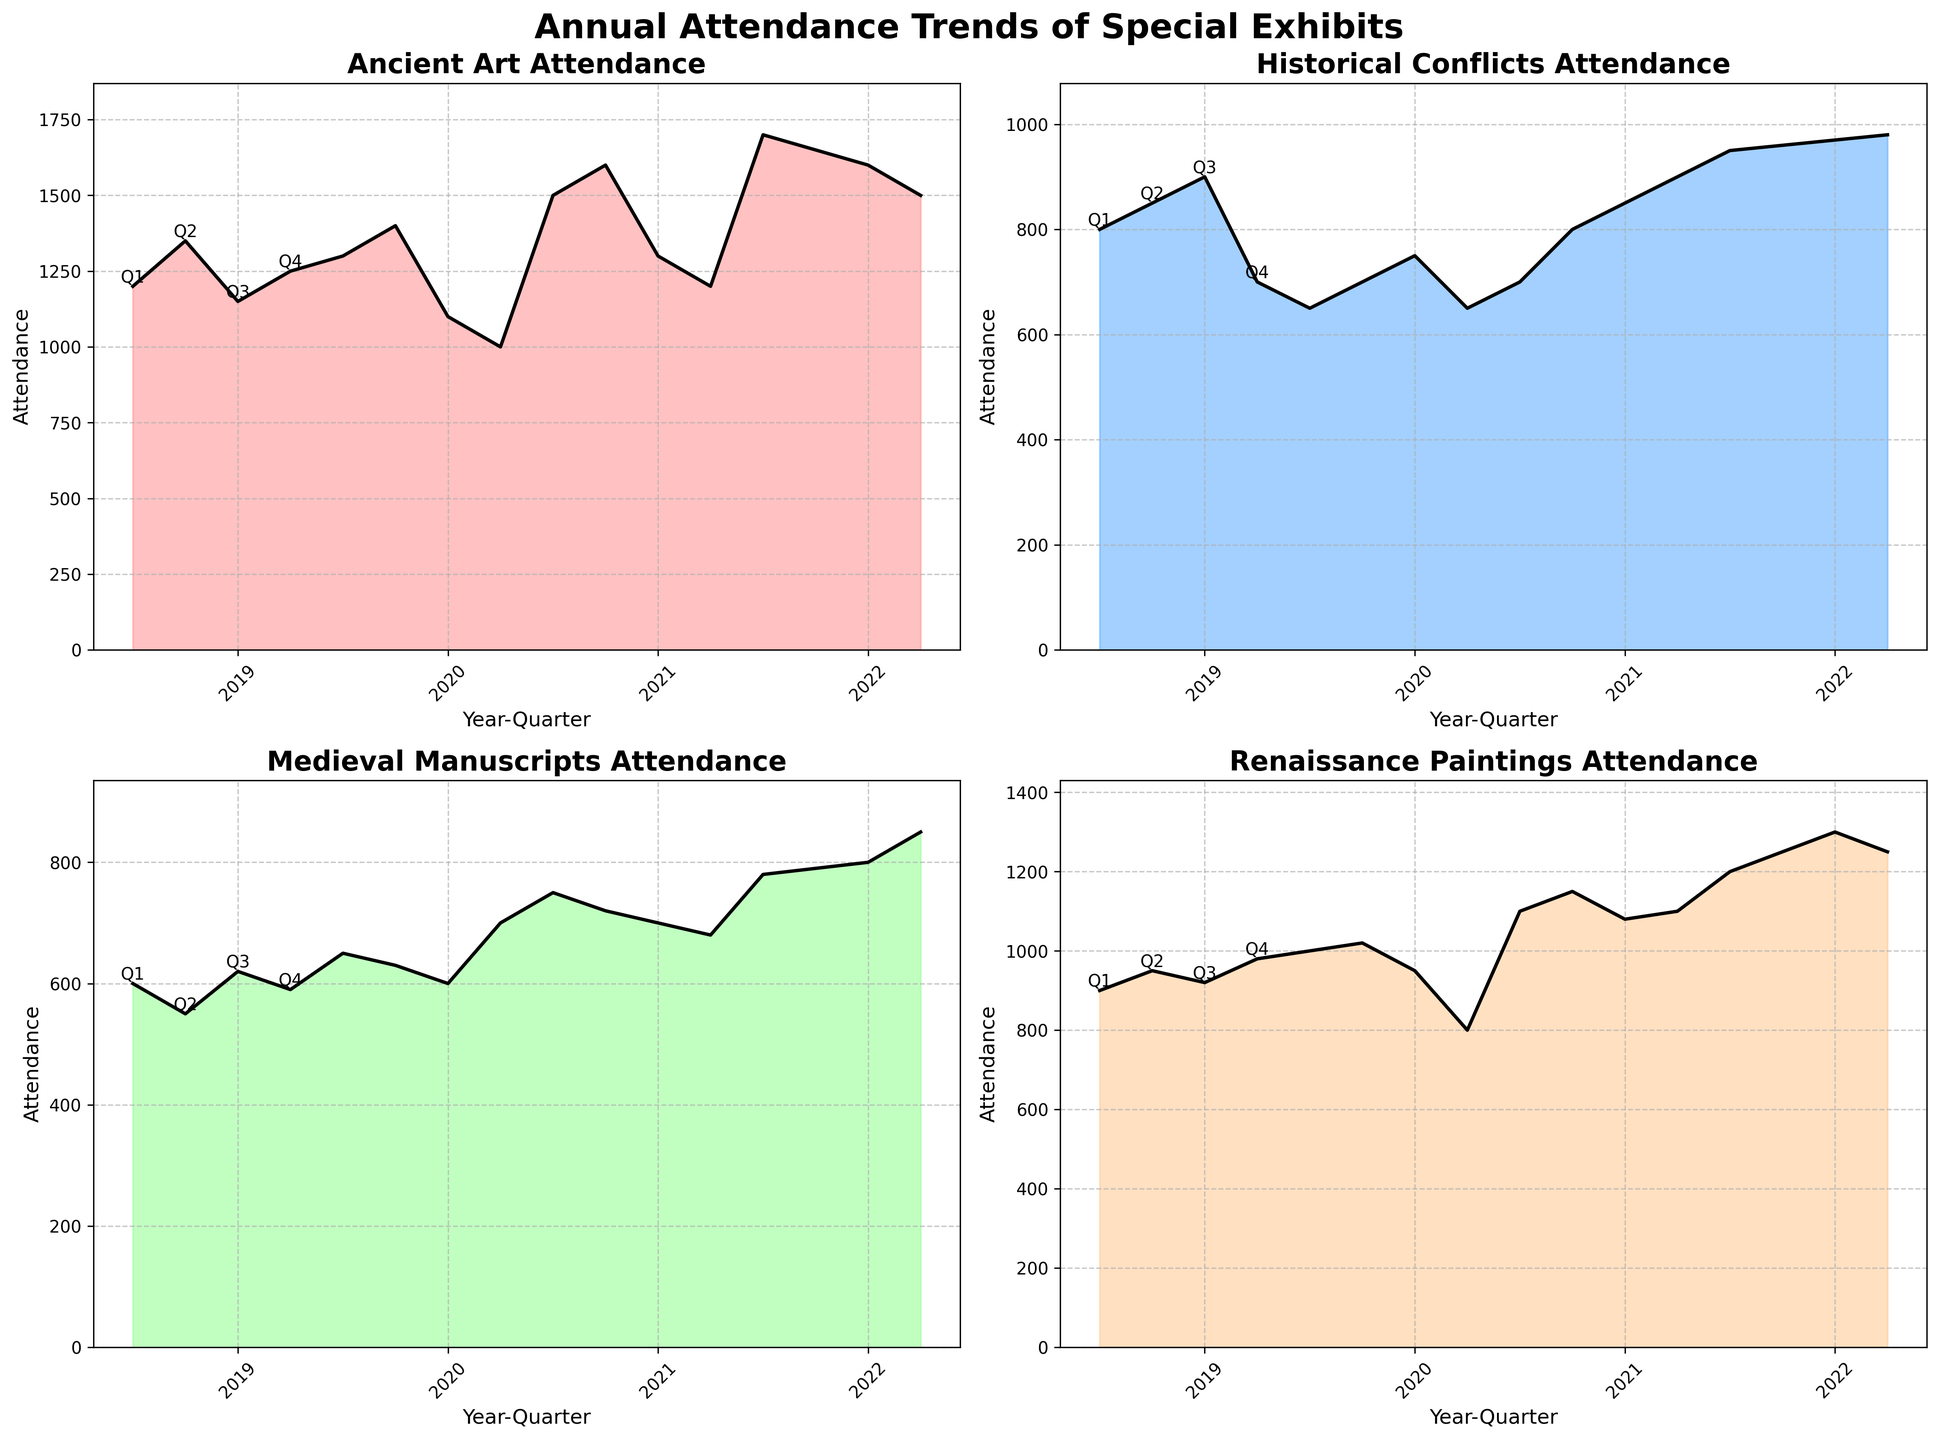How many subplots are there in the figure? The figure consists of a 2x2 grid, which means there are 4 subplots. Each subplot represents a different Exhibit Theme.
Answer: 4 What is the title of the figure? The title of the figure is displayed prominently above all subplots. It reads "Annual Attendance Trends of Special Exhibits."
Answer: Annual Attendance Trends of Special Exhibits Which exhibit theme had the highest attendance in any single quarter? By looking at the peaks of the area charts, the Ancient Art theme had the highest single-quarter attendance, specifically in Q1 of 2022, where the attendance was 1700.
Answer: Ancient Art In which year did Historical Conflicts exhibit theme show a consistent increase in attendance each quarter? By examining the subplots, specifically the Historical Conflicts chart, it is evident that the attendance increased every quarter during the year 2022.
Answer: 2022 How does the trend in attendance for Renaissance Paintings change from 2019 to 2022? Observing the Renaissance Paintings subplot, the attendance generally increases over the years from 2019 to 2022. There is a notable dip in Q4 of 2020, but the overall trend is upward.
Answer: Increasing Compare the attendance of Ancient Art and Medieval Manuscripts in Q4 of 2021. Which has higher attendance? Checking the Q4 2021 data points in the subplots, Ancient Art has an attendance of 1200, whereas Medieval Manuscripts has an attendance of 680.
Answer: Ancient Art Calculate the average attendance for Medieval Manuscripts in the year 2020. The attendance figures for Medieval Manuscripts in 2020 are 650, 630, 600, and 700. Summing these values gives 2580, and the average is calculated as 2580 / 4.
Answer: 645 Did any exhibit theme display a downward trend overall from 2019 to 2022? By examining each subplot, it is clear that no exhibit theme showed an overall downward trend from 2019 to 2022. All themes exhibit either upward trends or fluctuations but not consistent declines.
Answer: No Which quarter tends to have lower attendance compared to the other quarters, across all themes? By observing the subplots, Q3 seems to typically have lower attendance figures compared to other quarters across all themes. Peaks are often found in Q1 or Q2.
Answer: Q3 What is the subtitle of the subplot for 'Ancient Art'? Each subplot has a title specifying its theme. The title of the subplot for 'Ancient Art' is "Ancient Art Attendance".
Answer: Ancient Art Attendance 